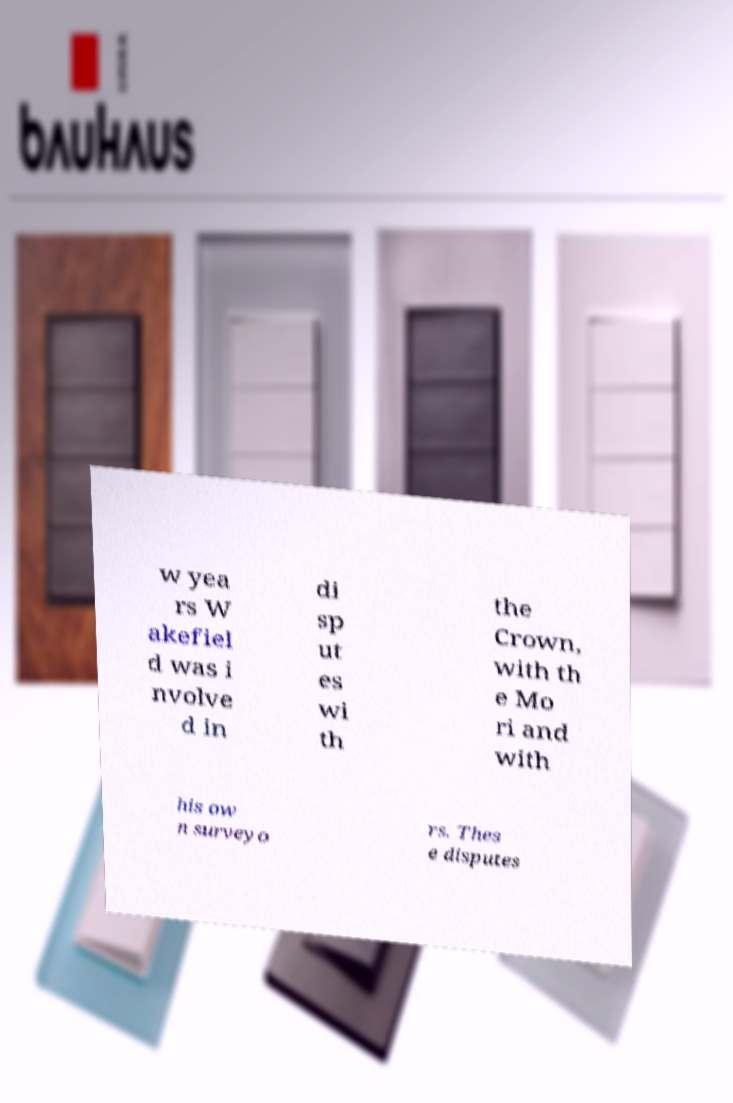Could you extract and type out the text from this image? w yea rs W akefiel d was i nvolve d in di sp ut es wi th the Crown, with th e Mo ri and with his ow n surveyo rs. Thes e disputes 